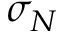<formula> <loc_0><loc_0><loc_500><loc_500>\sigma _ { N }</formula> 